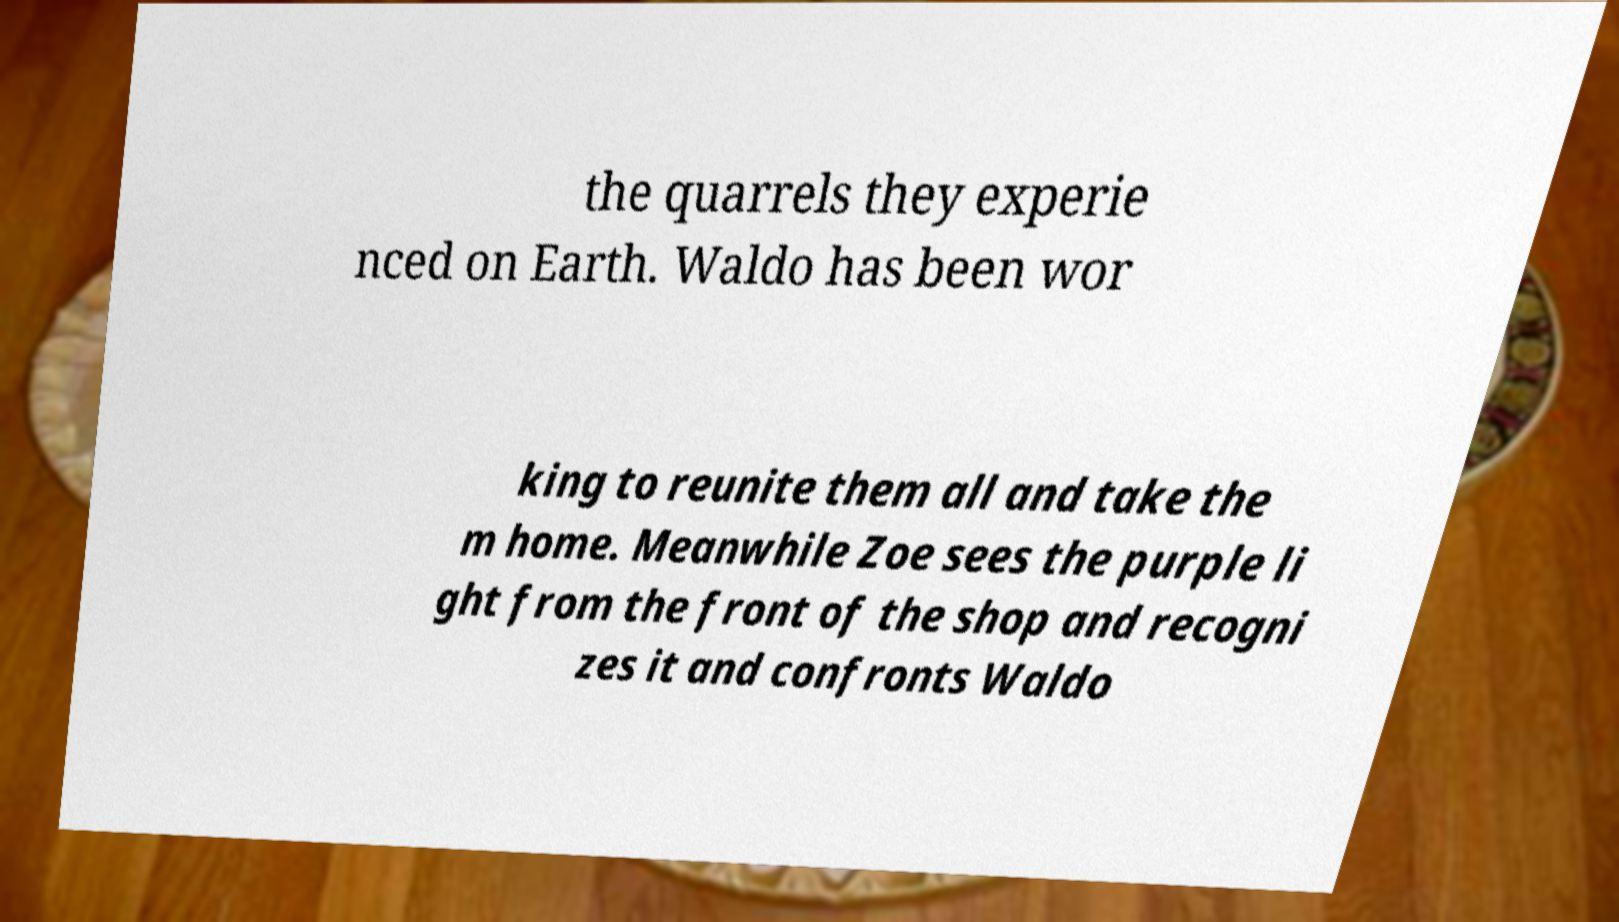I need the written content from this picture converted into text. Can you do that? the quarrels they experie nced on Earth. Waldo has been wor king to reunite them all and take the m home. Meanwhile Zoe sees the purple li ght from the front of the shop and recogni zes it and confronts Waldo 